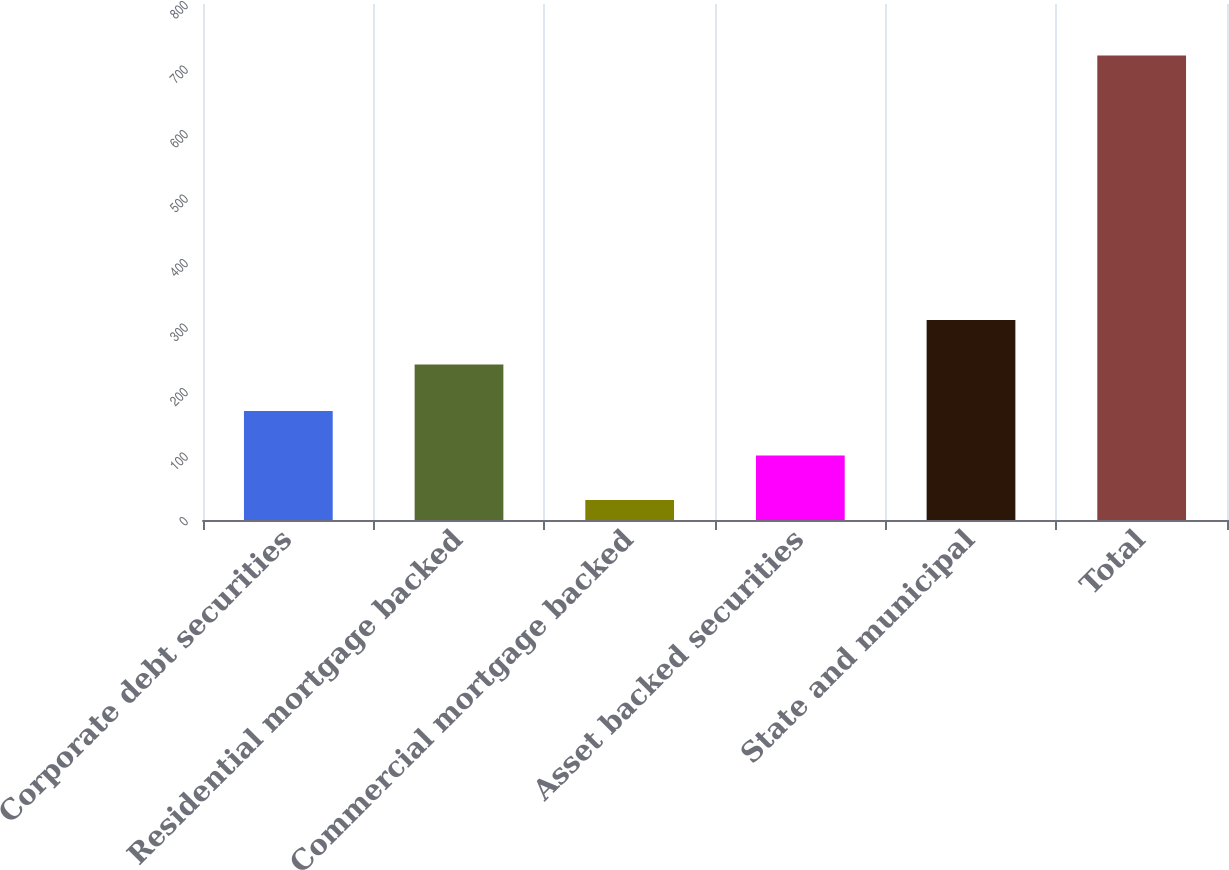<chart> <loc_0><loc_0><loc_500><loc_500><bar_chart><fcel>Corporate debt securities<fcel>Residential mortgage backed<fcel>Commercial mortgage backed<fcel>Asset backed securities<fcel>State and municipal<fcel>Total<nl><fcel>168.8<fcel>241<fcel>31<fcel>99.9<fcel>309.9<fcel>720<nl></chart> 